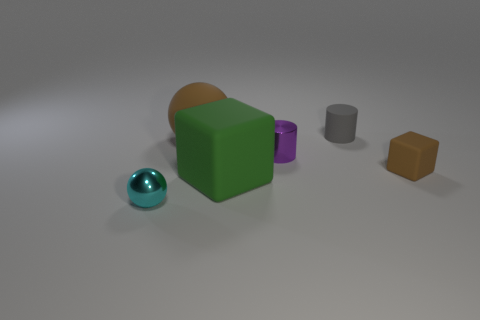The small matte object to the right of the cylinder that is behind the metallic object behind the cyan ball is what color? The small matte object you're referring to appears to be a cube-like shape with a distinctly warm and earthy color tone, which can accurately be described as brown. It’s placed slightly to the right of a taller cylinder, and both objects are positioned behind a glossy, metallic surface which is reflecting the nearby cyan-colored sphere. 